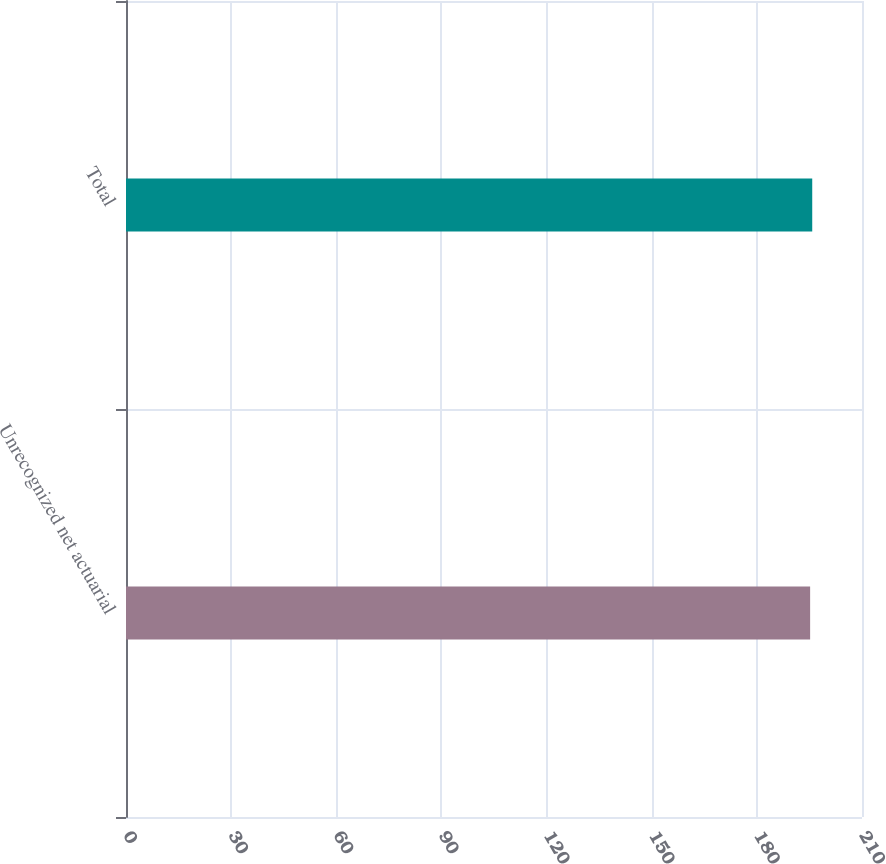Convert chart to OTSL. <chart><loc_0><loc_0><loc_500><loc_500><bar_chart><fcel>Unrecognized net actuarial<fcel>Total<nl><fcel>195.2<fcel>195.8<nl></chart> 